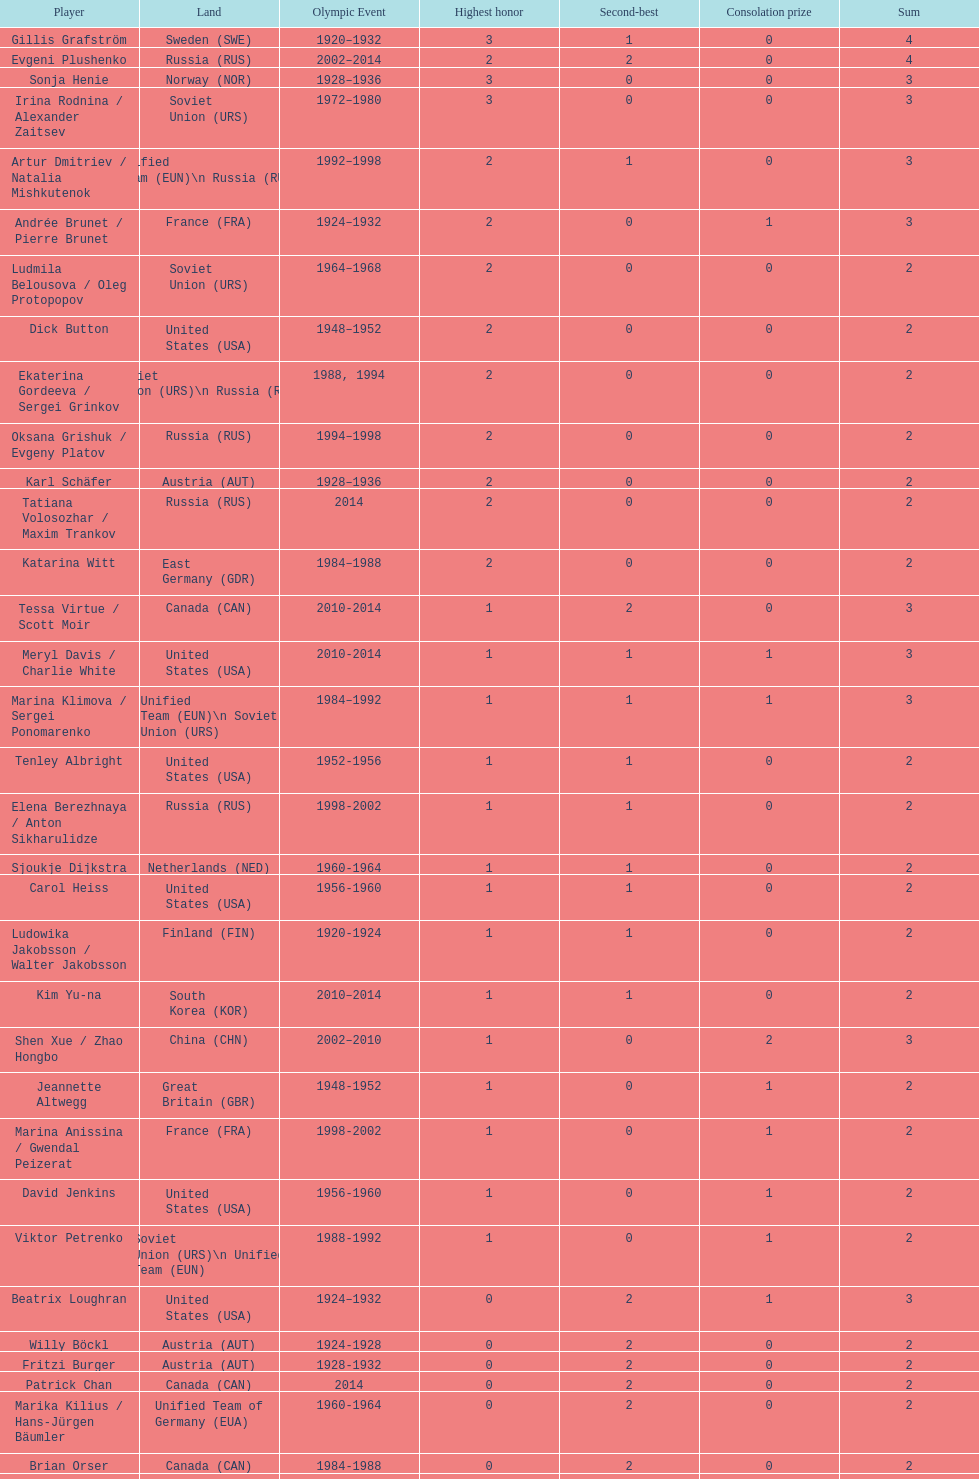Which athlete was from south korea after the year 2010? Kim Yu-na. 